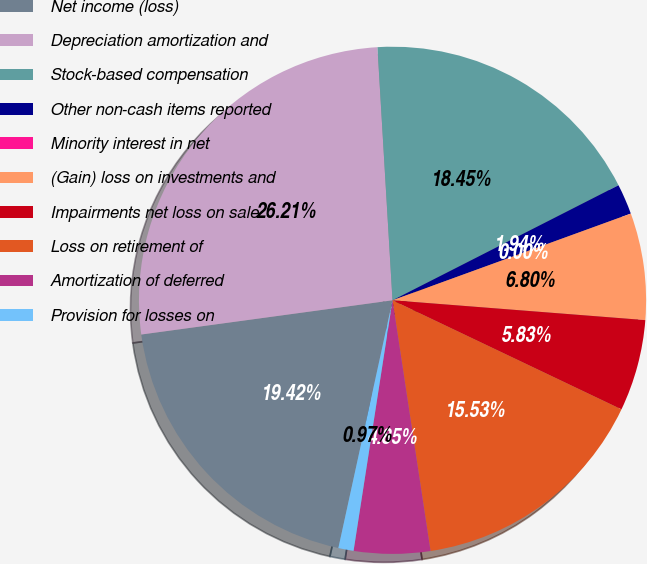<chart> <loc_0><loc_0><loc_500><loc_500><pie_chart><fcel>Net income (loss)<fcel>Depreciation amortization and<fcel>Stock-based compensation<fcel>Other non-cash items reported<fcel>Minority interest in net<fcel>(Gain) loss on investments and<fcel>Impairments net loss on sale<fcel>Loss on retirement of<fcel>Amortization of deferred<fcel>Provision for losses on<nl><fcel>19.42%<fcel>26.21%<fcel>18.45%<fcel>1.94%<fcel>0.0%<fcel>6.8%<fcel>5.83%<fcel>15.53%<fcel>4.85%<fcel>0.97%<nl></chart> 